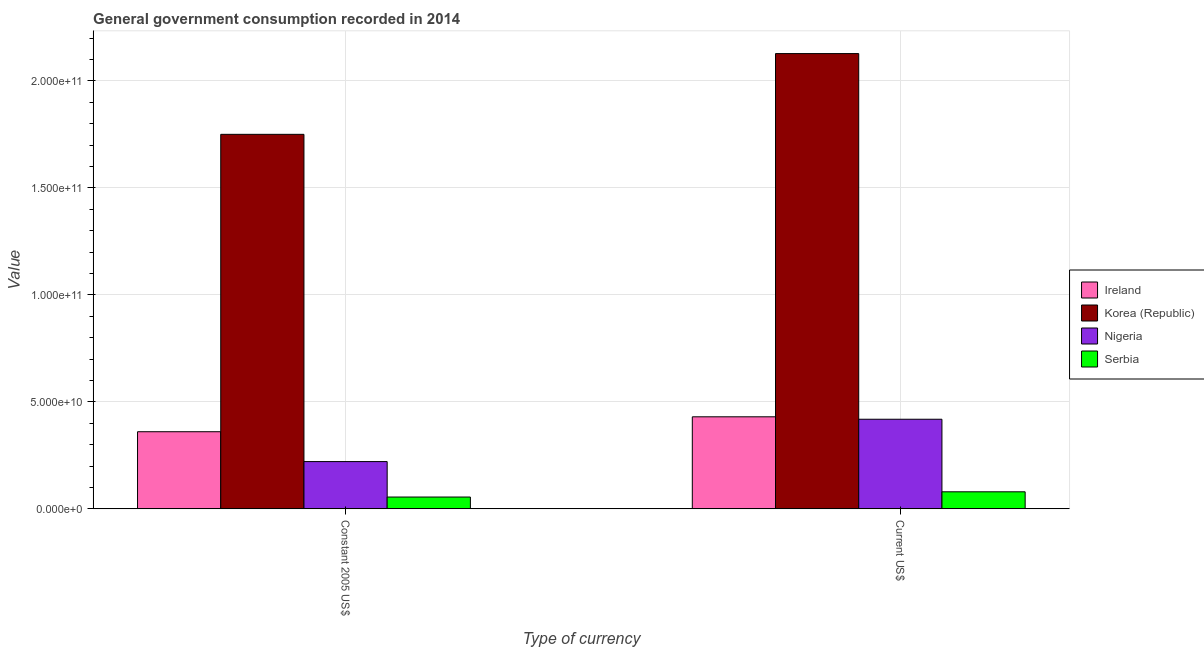How many different coloured bars are there?
Your answer should be compact. 4. Are the number of bars on each tick of the X-axis equal?
Provide a short and direct response. Yes. How many bars are there on the 2nd tick from the right?
Your answer should be compact. 4. What is the label of the 1st group of bars from the left?
Your answer should be compact. Constant 2005 US$. What is the value consumed in constant 2005 us$ in Ireland?
Your answer should be very brief. 3.60e+1. Across all countries, what is the maximum value consumed in current us$?
Your answer should be very brief. 2.13e+11. Across all countries, what is the minimum value consumed in current us$?
Your response must be concise. 7.96e+09. In which country was the value consumed in constant 2005 us$ maximum?
Provide a succinct answer. Korea (Republic). In which country was the value consumed in current us$ minimum?
Provide a short and direct response. Serbia. What is the total value consumed in constant 2005 us$ in the graph?
Give a very brief answer. 2.39e+11. What is the difference between the value consumed in current us$ in Ireland and that in Nigeria?
Your answer should be compact. 1.14e+09. What is the difference between the value consumed in constant 2005 us$ in Korea (Republic) and the value consumed in current us$ in Ireland?
Provide a short and direct response. 1.32e+11. What is the average value consumed in constant 2005 us$ per country?
Offer a terse response. 5.97e+1. What is the difference between the value consumed in current us$ and value consumed in constant 2005 us$ in Ireland?
Offer a very short reply. 6.97e+09. In how many countries, is the value consumed in current us$ greater than 150000000000 ?
Provide a succinct answer. 1. What is the ratio of the value consumed in constant 2005 us$ in Serbia to that in Korea (Republic)?
Provide a short and direct response. 0.03. In how many countries, is the value consumed in current us$ greater than the average value consumed in current us$ taken over all countries?
Offer a very short reply. 1. What does the 2nd bar from the right in Constant 2005 US$ represents?
Your answer should be compact. Nigeria. Are all the bars in the graph horizontal?
Your answer should be very brief. No. What is the difference between two consecutive major ticks on the Y-axis?
Give a very brief answer. 5.00e+1. Does the graph contain any zero values?
Your answer should be compact. No. What is the title of the graph?
Your answer should be very brief. General government consumption recorded in 2014. What is the label or title of the X-axis?
Ensure brevity in your answer.  Type of currency. What is the label or title of the Y-axis?
Provide a short and direct response. Value. What is the Value in Ireland in Constant 2005 US$?
Make the answer very short. 3.60e+1. What is the Value in Korea (Republic) in Constant 2005 US$?
Your response must be concise. 1.75e+11. What is the Value in Nigeria in Constant 2005 US$?
Your answer should be very brief. 2.21e+1. What is the Value in Serbia in Constant 2005 US$?
Offer a very short reply. 5.52e+09. What is the Value in Ireland in Current US$?
Provide a short and direct response. 4.30e+1. What is the Value of Korea (Republic) in Current US$?
Your response must be concise. 2.13e+11. What is the Value of Nigeria in Current US$?
Your response must be concise. 4.19e+1. What is the Value of Serbia in Current US$?
Keep it short and to the point. 7.96e+09. Across all Type of currency, what is the maximum Value of Ireland?
Make the answer very short. 4.30e+1. Across all Type of currency, what is the maximum Value of Korea (Republic)?
Your answer should be very brief. 2.13e+11. Across all Type of currency, what is the maximum Value of Nigeria?
Provide a short and direct response. 4.19e+1. Across all Type of currency, what is the maximum Value in Serbia?
Ensure brevity in your answer.  7.96e+09. Across all Type of currency, what is the minimum Value of Ireland?
Give a very brief answer. 3.60e+1. Across all Type of currency, what is the minimum Value in Korea (Republic)?
Make the answer very short. 1.75e+11. Across all Type of currency, what is the minimum Value of Nigeria?
Offer a terse response. 2.21e+1. Across all Type of currency, what is the minimum Value of Serbia?
Your answer should be compact. 5.52e+09. What is the total Value of Ireland in the graph?
Make the answer very short. 7.91e+1. What is the total Value in Korea (Republic) in the graph?
Your answer should be compact. 3.88e+11. What is the total Value in Nigeria in the graph?
Provide a short and direct response. 6.40e+1. What is the total Value of Serbia in the graph?
Provide a succinct answer. 1.35e+1. What is the difference between the Value in Ireland in Constant 2005 US$ and that in Current US$?
Your response must be concise. -6.97e+09. What is the difference between the Value in Korea (Republic) in Constant 2005 US$ and that in Current US$?
Give a very brief answer. -3.77e+1. What is the difference between the Value of Nigeria in Constant 2005 US$ and that in Current US$?
Your response must be concise. -1.98e+1. What is the difference between the Value in Serbia in Constant 2005 US$ and that in Current US$?
Your answer should be very brief. -2.45e+09. What is the difference between the Value of Ireland in Constant 2005 US$ and the Value of Korea (Republic) in Current US$?
Provide a succinct answer. -1.77e+11. What is the difference between the Value of Ireland in Constant 2005 US$ and the Value of Nigeria in Current US$?
Give a very brief answer. -5.83e+09. What is the difference between the Value of Ireland in Constant 2005 US$ and the Value of Serbia in Current US$?
Make the answer very short. 2.81e+1. What is the difference between the Value in Korea (Republic) in Constant 2005 US$ and the Value in Nigeria in Current US$?
Your answer should be very brief. 1.33e+11. What is the difference between the Value of Korea (Republic) in Constant 2005 US$ and the Value of Serbia in Current US$?
Your response must be concise. 1.67e+11. What is the difference between the Value of Nigeria in Constant 2005 US$ and the Value of Serbia in Current US$?
Offer a very short reply. 1.41e+1. What is the average Value in Ireland per Type of currency?
Your response must be concise. 3.95e+1. What is the average Value in Korea (Republic) per Type of currency?
Ensure brevity in your answer.  1.94e+11. What is the average Value in Nigeria per Type of currency?
Ensure brevity in your answer.  3.20e+1. What is the average Value in Serbia per Type of currency?
Offer a very short reply. 6.74e+09. What is the difference between the Value of Ireland and Value of Korea (Republic) in Constant 2005 US$?
Make the answer very short. -1.39e+11. What is the difference between the Value in Ireland and Value in Nigeria in Constant 2005 US$?
Make the answer very short. 1.40e+1. What is the difference between the Value in Ireland and Value in Serbia in Constant 2005 US$?
Keep it short and to the point. 3.05e+1. What is the difference between the Value in Korea (Republic) and Value in Nigeria in Constant 2005 US$?
Your response must be concise. 1.53e+11. What is the difference between the Value of Korea (Republic) and Value of Serbia in Constant 2005 US$?
Provide a short and direct response. 1.70e+11. What is the difference between the Value in Nigeria and Value in Serbia in Constant 2005 US$?
Provide a succinct answer. 1.66e+1. What is the difference between the Value in Ireland and Value in Korea (Republic) in Current US$?
Your answer should be very brief. -1.70e+11. What is the difference between the Value of Ireland and Value of Nigeria in Current US$?
Your answer should be very brief. 1.14e+09. What is the difference between the Value of Ireland and Value of Serbia in Current US$?
Ensure brevity in your answer.  3.51e+1. What is the difference between the Value of Korea (Republic) and Value of Nigeria in Current US$?
Make the answer very short. 1.71e+11. What is the difference between the Value in Korea (Republic) and Value in Serbia in Current US$?
Provide a succinct answer. 2.05e+11. What is the difference between the Value of Nigeria and Value of Serbia in Current US$?
Your answer should be compact. 3.39e+1. What is the ratio of the Value of Ireland in Constant 2005 US$ to that in Current US$?
Keep it short and to the point. 0.84. What is the ratio of the Value in Korea (Republic) in Constant 2005 US$ to that in Current US$?
Offer a terse response. 0.82. What is the ratio of the Value in Nigeria in Constant 2005 US$ to that in Current US$?
Give a very brief answer. 0.53. What is the ratio of the Value of Serbia in Constant 2005 US$ to that in Current US$?
Your answer should be very brief. 0.69. What is the difference between the highest and the second highest Value of Ireland?
Offer a very short reply. 6.97e+09. What is the difference between the highest and the second highest Value of Korea (Republic)?
Keep it short and to the point. 3.77e+1. What is the difference between the highest and the second highest Value of Nigeria?
Offer a very short reply. 1.98e+1. What is the difference between the highest and the second highest Value of Serbia?
Keep it short and to the point. 2.45e+09. What is the difference between the highest and the lowest Value of Ireland?
Keep it short and to the point. 6.97e+09. What is the difference between the highest and the lowest Value of Korea (Republic)?
Provide a short and direct response. 3.77e+1. What is the difference between the highest and the lowest Value in Nigeria?
Offer a very short reply. 1.98e+1. What is the difference between the highest and the lowest Value of Serbia?
Provide a short and direct response. 2.45e+09. 